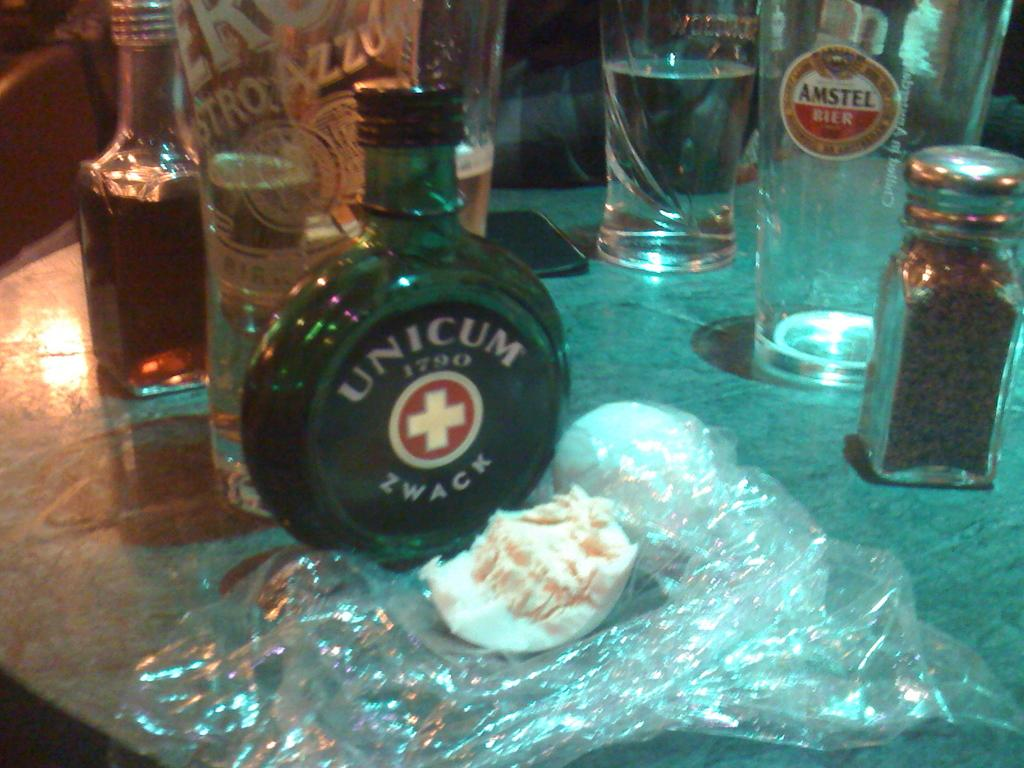<image>
Render a clear and concise summary of the photo. table with bottle of unicum zwack, anstel beer, and other things 